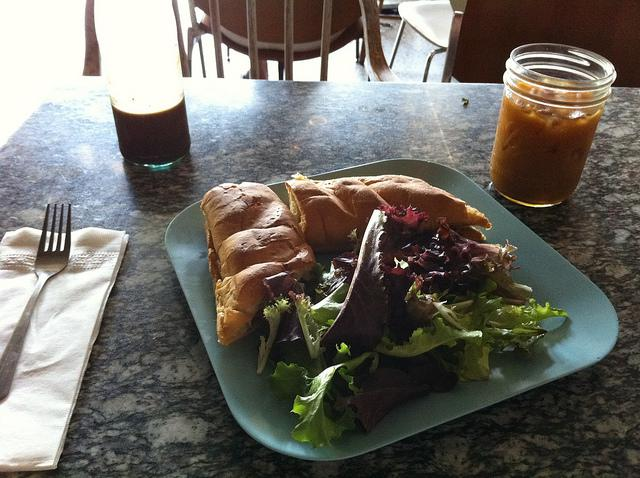What type of drink in in the jar? Please explain your reasoning. iced coffee. The drink is light brown with ice on it. 